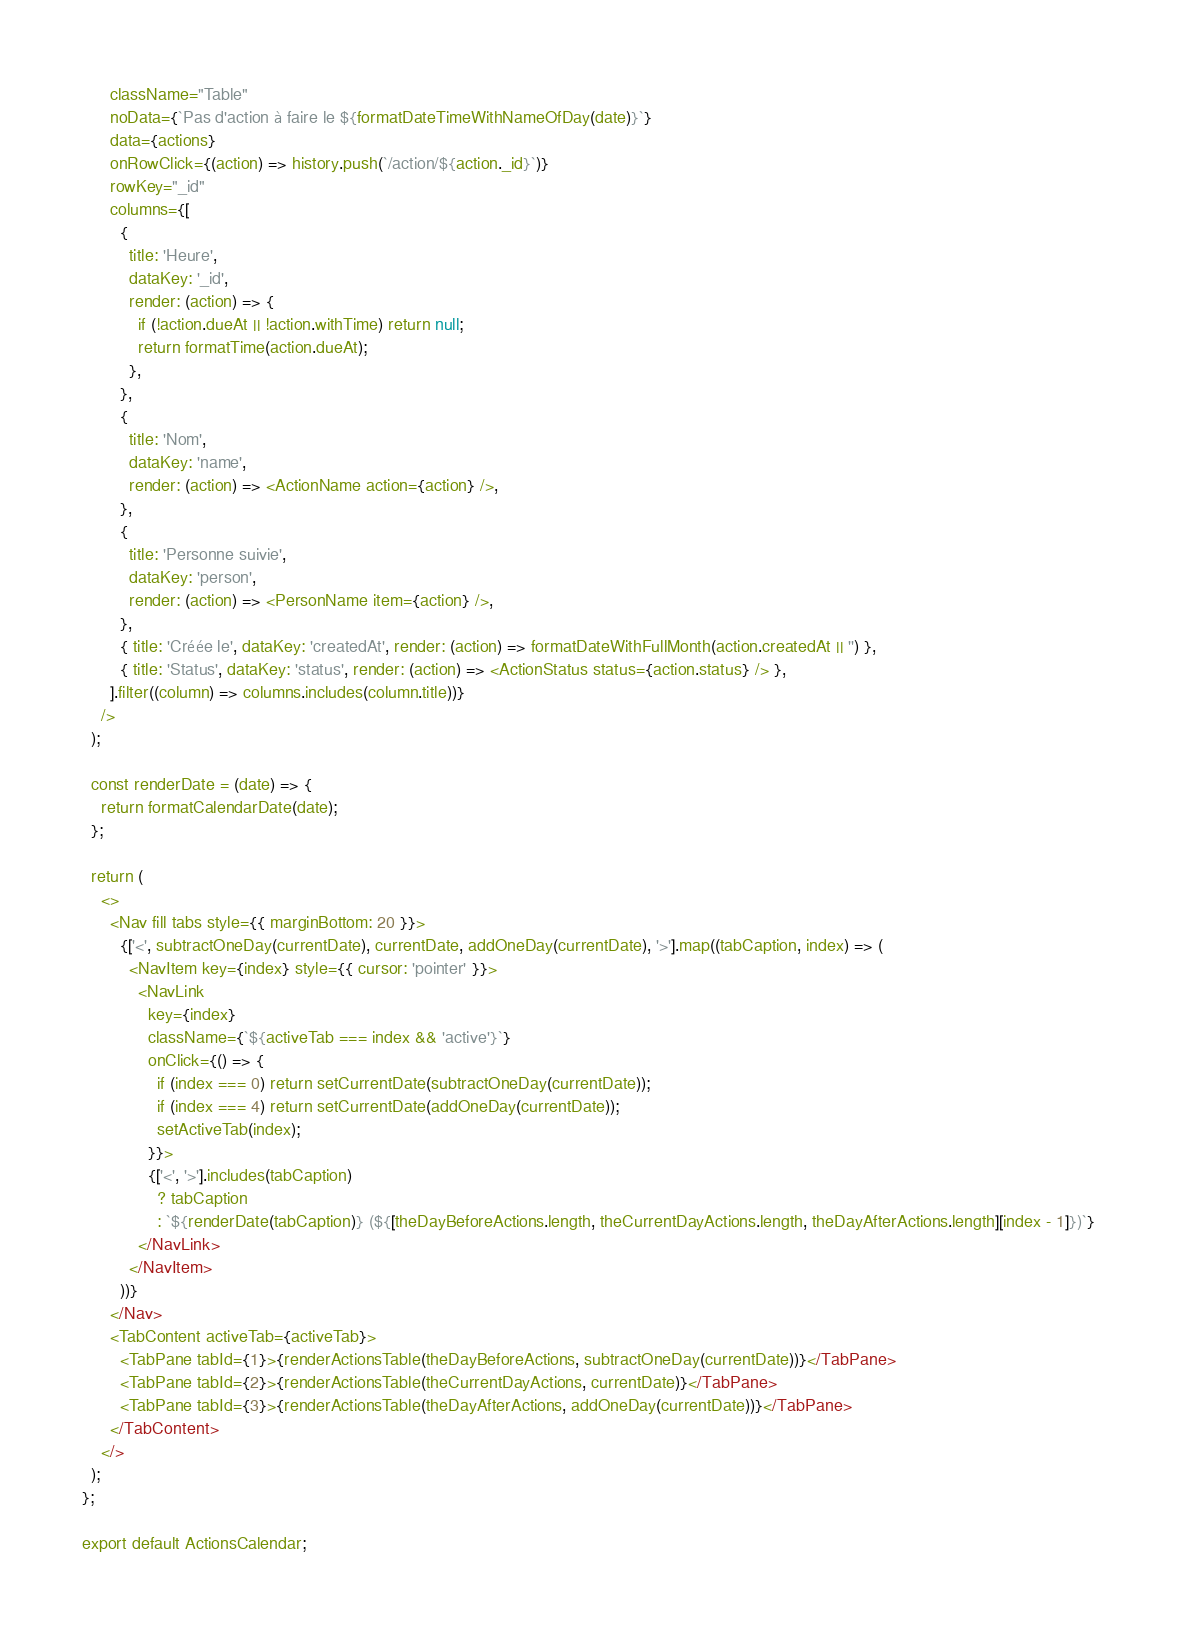<code> <loc_0><loc_0><loc_500><loc_500><_JavaScript_>      className="Table"
      noData={`Pas d'action à faire le ${formatDateTimeWithNameOfDay(date)}`}
      data={actions}
      onRowClick={(action) => history.push(`/action/${action._id}`)}
      rowKey="_id"
      columns={[
        {
          title: 'Heure',
          dataKey: '_id',
          render: (action) => {
            if (!action.dueAt || !action.withTime) return null;
            return formatTime(action.dueAt);
          },
        },
        {
          title: 'Nom',
          dataKey: 'name',
          render: (action) => <ActionName action={action} />,
        },
        {
          title: 'Personne suivie',
          dataKey: 'person',
          render: (action) => <PersonName item={action} />,
        },
        { title: 'Créée le', dataKey: 'createdAt', render: (action) => formatDateWithFullMonth(action.createdAt || '') },
        { title: 'Status', dataKey: 'status', render: (action) => <ActionStatus status={action.status} /> },
      ].filter((column) => columns.includes(column.title))}
    />
  );

  const renderDate = (date) => {
    return formatCalendarDate(date);
  };

  return (
    <>
      <Nav fill tabs style={{ marginBottom: 20 }}>
        {['<', subtractOneDay(currentDate), currentDate, addOneDay(currentDate), '>'].map((tabCaption, index) => (
          <NavItem key={index} style={{ cursor: 'pointer' }}>
            <NavLink
              key={index}
              className={`${activeTab === index && 'active'}`}
              onClick={() => {
                if (index === 0) return setCurrentDate(subtractOneDay(currentDate));
                if (index === 4) return setCurrentDate(addOneDay(currentDate));
                setActiveTab(index);
              }}>
              {['<', '>'].includes(tabCaption)
                ? tabCaption
                : `${renderDate(tabCaption)} (${[theDayBeforeActions.length, theCurrentDayActions.length, theDayAfterActions.length][index - 1]})`}
            </NavLink>
          </NavItem>
        ))}
      </Nav>
      <TabContent activeTab={activeTab}>
        <TabPane tabId={1}>{renderActionsTable(theDayBeforeActions, subtractOneDay(currentDate))}</TabPane>
        <TabPane tabId={2}>{renderActionsTable(theCurrentDayActions, currentDate)}</TabPane>
        <TabPane tabId={3}>{renderActionsTable(theDayAfterActions, addOneDay(currentDate))}</TabPane>
      </TabContent>
    </>
  );
};

export default ActionsCalendar;
</code> 